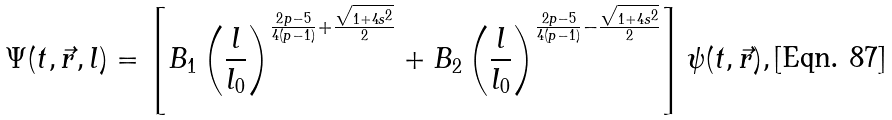Convert formula to latex. <formula><loc_0><loc_0><loc_500><loc_500>\Psi ( t , \vec { r } , l ) = \left [ B _ { 1 } \left ( \frac { l } { l _ { 0 } } \right ) ^ { \frac { 2 p - 5 } { 4 ( p - 1 ) } + \frac { \sqrt { 1 + 4 s ^ { 2 } } } { 2 } } + B _ { 2 } \left ( \frac { l } { l _ { 0 } } \right ) ^ { \frac { 2 p - 5 } { 4 ( p - 1 ) } - \frac { \sqrt { 1 + 4 s ^ { 2 } } } { 2 } } \right ] \psi ( t , \vec { r } ) ,</formula> 